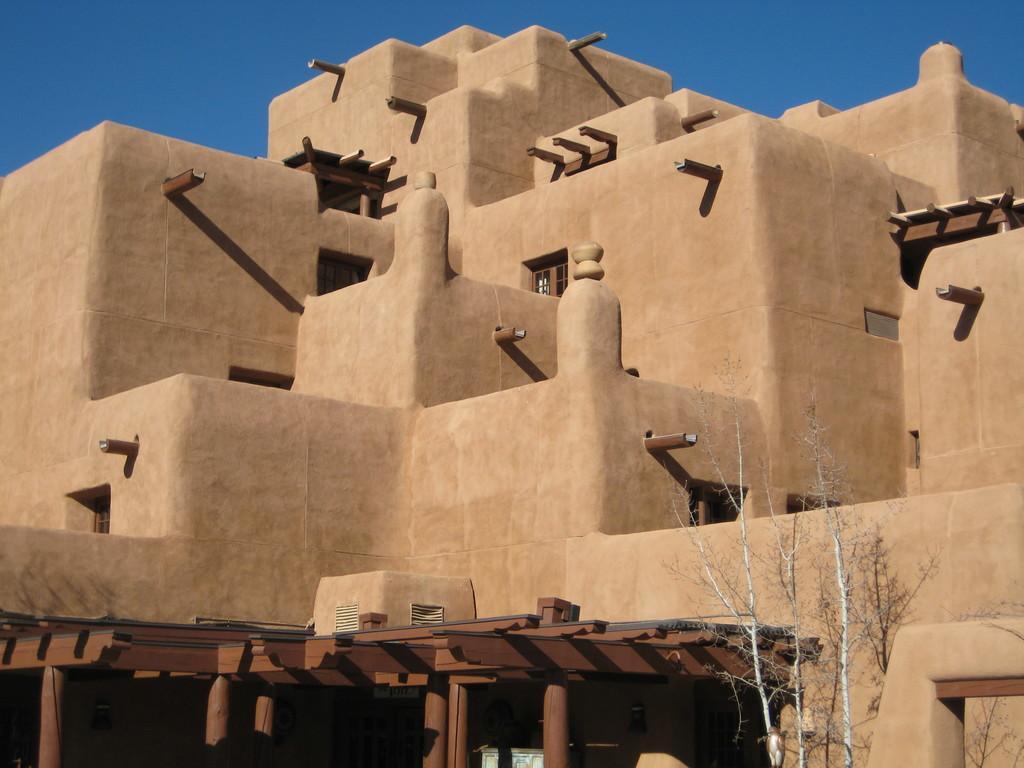Describe this image in one or two sentences. The picture consists of an old architecture. In the foreground there is a tree. Sky is sunny. 